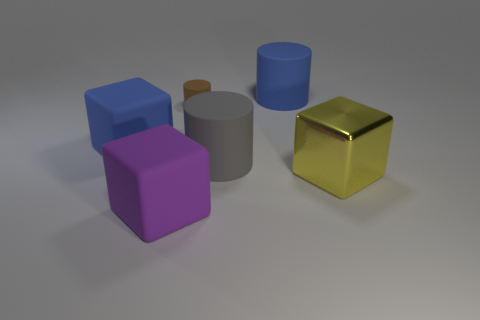There is a large rubber thing that is in front of the large metallic cube; is it the same shape as the small matte thing?
Offer a very short reply. No. How many yellow objects are cylinders or big shiny objects?
Offer a terse response. 1. There is a thing that is behind the blue block and in front of the blue rubber cylinder; what shape is it?
Your answer should be compact. Cylinder. There is a small brown thing; are there any big gray things right of it?
Your response must be concise. Yes. What is the size of the gray matte object that is the same shape as the tiny brown object?
Your answer should be compact. Large. Are there any other things that are the same size as the brown rubber object?
Keep it short and to the point. No. Does the small thing have the same shape as the large metallic thing?
Your answer should be compact. No. There is a blue rubber object in front of the small rubber cylinder behind the big purple rubber object; how big is it?
Your answer should be compact. Large. There is another rubber object that is the same shape as the purple thing; what color is it?
Provide a succinct answer. Blue. The purple object is what size?
Your answer should be very brief. Large. 